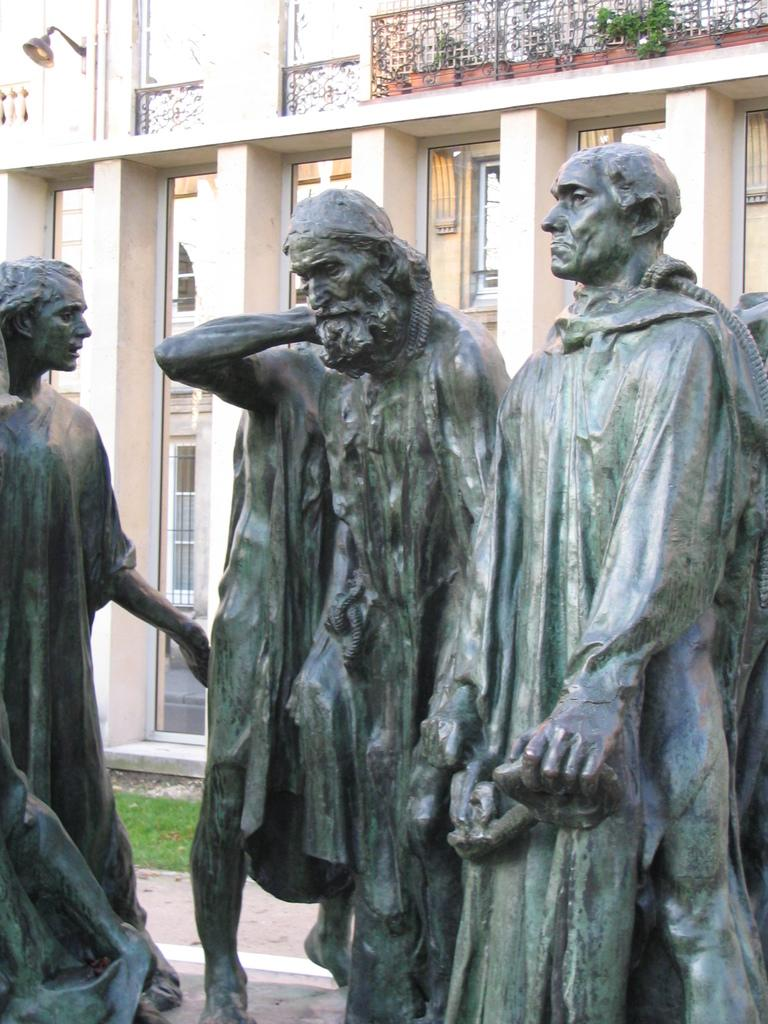What type of art is present in the image? There are sculptures in the image. What can be seen in the distance behind the sculptures? There is a building in the background of the image. What architectural feature is visible in the image? There is a window in the image. What source of illumination is present in the image? There is a light in the image. What type of natural environment is visible in the image? There is grass in the image. What type of pain is the mother experiencing in the image? There is no mother or indication of pain present in the image; it features sculptures, a building, a window, a light, and grass. 